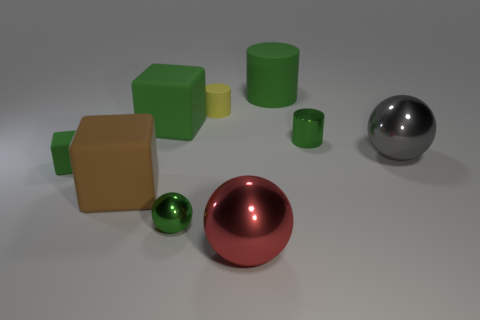Add 1 yellow matte blocks. How many objects exist? 10 Subtract all balls. How many objects are left? 6 Add 9 cyan metallic cubes. How many cyan metallic cubes exist? 9 Subtract 0 blue cubes. How many objects are left? 9 Subtract all tiny green objects. Subtract all balls. How many objects are left? 3 Add 8 big brown rubber cubes. How many big brown rubber cubes are left? 9 